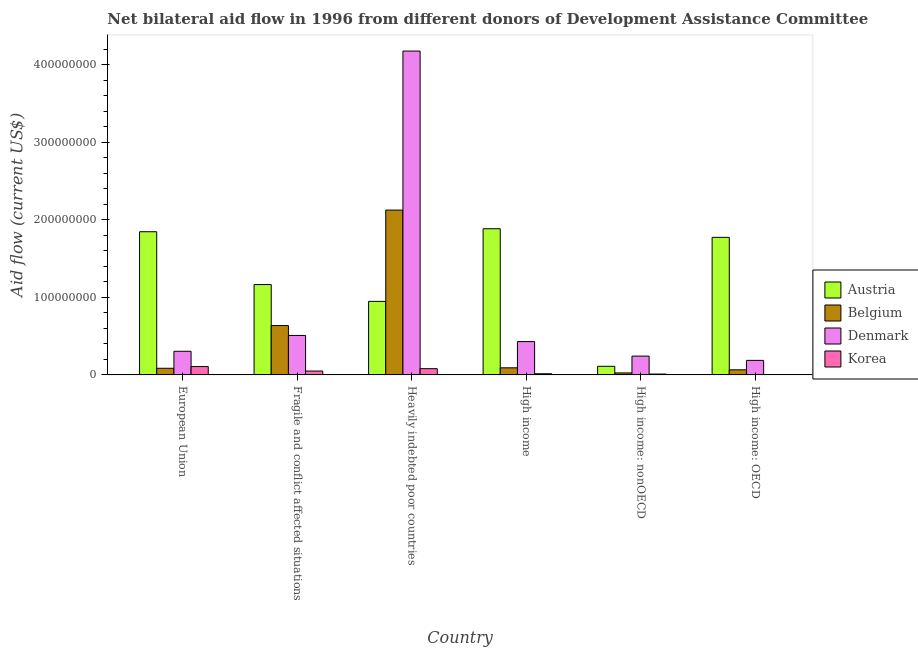How many different coloured bars are there?
Keep it short and to the point. 4. Are the number of bars on each tick of the X-axis equal?
Make the answer very short. Yes. How many bars are there on the 3rd tick from the right?
Keep it short and to the point. 4. What is the label of the 1st group of bars from the left?
Your response must be concise. European Union. What is the amount of aid given by denmark in Fragile and conflict affected situations?
Provide a short and direct response. 5.09e+07. Across all countries, what is the maximum amount of aid given by korea?
Your answer should be very brief. 1.08e+07. Across all countries, what is the minimum amount of aid given by korea?
Offer a terse response. 3.50e+05. In which country was the amount of aid given by korea maximum?
Offer a terse response. European Union. In which country was the amount of aid given by korea minimum?
Offer a terse response. High income: OECD. What is the total amount of aid given by austria in the graph?
Give a very brief answer. 7.73e+08. What is the difference between the amount of aid given by denmark in European Union and that in High income: OECD?
Make the answer very short. 1.17e+07. What is the difference between the amount of aid given by denmark in European Union and the amount of aid given by belgium in Heavily indebted poor countries?
Keep it short and to the point. -1.82e+08. What is the average amount of aid given by denmark per country?
Offer a terse response. 9.75e+07. What is the difference between the amount of aid given by denmark and amount of aid given by austria in European Union?
Your response must be concise. -1.54e+08. What is the ratio of the amount of aid given by austria in European Union to that in High income: OECD?
Your answer should be compact. 1.04. Is the amount of aid given by belgium in Fragile and conflict affected situations less than that in High income: nonOECD?
Ensure brevity in your answer.  No. What is the difference between the highest and the second highest amount of aid given by belgium?
Offer a very short reply. 1.49e+08. What is the difference between the highest and the lowest amount of aid given by austria?
Give a very brief answer. 1.77e+08. In how many countries, is the amount of aid given by belgium greater than the average amount of aid given by belgium taken over all countries?
Your response must be concise. 2. What does the 1st bar from the right in Fragile and conflict affected situations represents?
Provide a succinct answer. Korea. Is it the case that in every country, the sum of the amount of aid given by austria and amount of aid given by belgium is greater than the amount of aid given by denmark?
Give a very brief answer. No. How many bars are there?
Make the answer very short. 24. Are all the bars in the graph horizontal?
Your answer should be compact. No. What is the difference between two consecutive major ticks on the Y-axis?
Your answer should be very brief. 1.00e+08. Are the values on the major ticks of Y-axis written in scientific E-notation?
Keep it short and to the point. No. Where does the legend appear in the graph?
Your response must be concise. Center right. How many legend labels are there?
Provide a short and direct response. 4. How are the legend labels stacked?
Provide a succinct answer. Vertical. What is the title of the graph?
Keep it short and to the point. Net bilateral aid flow in 1996 from different donors of Development Assistance Committee. What is the label or title of the X-axis?
Give a very brief answer. Country. What is the Aid flow (current US$) in Austria in European Union?
Keep it short and to the point. 1.85e+08. What is the Aid flow (current US$) in Belgium in European Union?
Offer a very short reply. 8.55e+06. What is the Aid flow (current US$) of Denmark in European Union?
Offer a very short reply. 3.05e+07. What is the Aid flow (current US$) in Korea in European Union?
Offer a terse response. 1.08e+07. What is the Aid flow (current US$) of Austria in Fragile and conflict affected situations?
Offer a terse response. 1.16e+08. What is the Aid flow (current US$) in Belgium in Fragile and conflict affected situations?
Provide a succinct answer. 6.36e+07. What is the Aid flow (current US$) of Denmark in Fragile and conflict affected situations?
Offer a terse response. 5.09e+07. What is the Aid flow (current US$) of Korea in Fragile and conflict affected situations?
Ensure brevity in your answer.  5.00e+06. What is the Aid flow (current US$) of Austria in Heavily indebted poor countries?
Give a very brief answer. 9.48e+07. What is the Aid flow (current US$) of Belgium in Heavily indebted poor countries?
Give a very brief answer. 2.12e+08. What is the Aid flow (current US$) in Denmark in Heavily indebted poor countries?
Offer a very short reply. 4.17e+08. What is the Aid flow (current US$) of Korea in Heavily indebted poor countries?
Provide a succinct answer. 8.06e+06. What is the Aid flow (current US$) of Austria in High income?
Keep it short and to the point. 1.88e+08. What is the Aid flow (current US$) of Belgium in High income?
Your response must be concise. 9.15e+06. What is the Aid flow (current US$) of Denmark in High income?
Keep it short and to the point. 4.30e+07. What is the Aid flow (current US$) in Korea in High income?
Provide a succinct answer. 1.48e+06. What is the Aid flow (current US$) in Austria in High income: nonOECD?
Make the answer very short. 1.11e+07. What is the Aid flow (current US$) of Belgium in High income: nonOECD?
Your answer should be compact. 2.58e+06. What is the Aid flow (current US$) in Denmark in High income: nonOECD?
Your response must be concise. 2.42e+07. What is the Aid flow (current US$) in Korea in High income: nonOECD?
Keep it short and to the point. 1.13e+06. What is the Aid flow (current US$) of Austria in High income: OECD?
Your response must be concise. 1.77e+08. What is the Aid flow (current US$) in Belgium in High income: OECD?
Your response must be concise. 6.57e+06. What is the Aid flow (current US$) of Denmark in High income: OECD?
Your answer should be compact. 1.87e+07. What is the Aid flow (current US$) of Korea in High income: OECD?
Offer a terse response. 3.50e+05. Across all countries, what is the maximum Aid flow (current US$) in Austria?
Offer a terse response. 1.88e+08. Across all countries, what is the maximum Aid flow (current US$) of Belgium?
Provide a short and direct response. 2.12e+08. Across all countries, what is the maximum Aid flow (current US$) of Denmark?
Offer a very short reply. 4.17e+08. Across all countries, what is the maximum Aid flow (current US$) in Korea?
Offer a very short reply. 1.08e+07. Across all countries, what is the minimum Aid flow (current US$) in Austria?
Provide a short and direct response. 1.11e+07. Across all countries, what is the minimum Aid flow (current US$) of Belgium?
Your answer should be very brief. 2.58e+06. Across all countries, what is the minimum Aid flow (current US$) in Denmark?
Provide a succinct answer. 1.87e+07. Across all countries, what is the minimum Aid flow (current US$) of Korea?
Provide a short and direct response. 3.50e+05. What is the total Aid flow (current US$) in Austria in the graph?
Give a very brief answer. 7.73e+08. What is the total Aid flow (current US$) in Belgium in the graph?
Ensure brevity in your answer.  3.03e+08. What is the total Aid flow (current US$) in Denmark in the graph?
Offer a terse response. 5.85e+08. What is the total Aid flow (current US$) in Korea in the graph?
Provide a succinct answer. 2.68e+07. What is the difference between the Aid flow (current US$) of Austria in European Union and that in Fragile and conflict affected situations?
Provide a succinct answer. 6.81e+07. What is the difference between the Aid flow (current US$) of Belgium in European Union and that in Fragile and conflict affected situations?
Ensure brevity in your answer.  -5.50e+07. What is the difference between the Aid flow (current US$) of Denmark in European Union and that in Fragile and conflict affected situations?
Your response must be concise. -2.04e+07. What is the difference between the Aid flow (current US$) in Korea in European Union and that in Fragile and conflict affected situations?
Provide a short and direct response. 5.77e+06. What is the difference between the Aid flow (current US$) of Austria in European Union and that in Heavily indebted poor countries?
Make the answer very short. 8.98e+07. What is the difference between the Aid flow (current US$) in Belgium in European Union and that in Heavily indebted poor countries?
Your response must be concise. -2.04e+08. What is the difference between the Aid flow (current US$) in Denmark in European Union and that in Heavily indebted poor countries?
Your answer should be compact. -3.87e+08. What is the difference between the Aid flow (current US$) in Korea in European Union and that in Heavily indebted poor countries?
Make the answer very short. 2.71e+06. What is the difference between the Aid flow (current US$) in Austria in European Union and that in High income?
Give a very brief answer. -3.84e+06. What is the difference between the Aid flow (current US$) in Belgium in European Union and that in High income?
Your answer should be very brief. -6.00e+05. What is the difference between the Aid flow (current US$) of Denmark in European Union and that in High income?
Make the answer very short. -1.25e+07. What is the difference between the Aid flow (current US$) in Korea in European Union and that in High income?
Offer a very short reply. 9.29e+06. What is the difference between the Aid flow (current US$) in Austria in European Union and that in High income: nonOECD?
Give a very brief answer. 1.74e+08. What is the difference between the Aid flow (current US$) in Belgium in European Union and that in High income: nonOECD?
Provide a succinct answer. 5.97e+06. What is the difference between the Aid flow (current US$) in Denmark in European Union and that in High income: nonOECD?
Keep it short and to the point. 6.23e+06. What is the difference between the Aid flow (current US$) of Korea in European Union and that in High income: nonOECD?
Keep it short and to the point. 9.64e+06. What is the difference between the Aid flow (current US$) of Austria in European Union and that in High income: OECD?
Keep it short and to the point. 7.25e+06. What is the difference between the Aid flow (current US$) of Belgium in European Union and that in High income: OECD?
Ensure brevity in your answer.  1.98e+06. What is the difference between the Aid flow (current US$) in Denmark in European Union and that in High income: OECD?
Ensure brevity in your answer.  1.17e+07. What is the difference between the Aid flow (current US$) of Korea in European Union and that in High income: OECD?
Offer a very short reply. 1.04e+07. What is the difference between the Aid flow (current US$) of Austria in Fragile and conflict affected situations and that in Heavily indebted poor countries?
Offer a very short reply. 2.17e+07. What is the difference between the Aid flow (current US$) of Belgium in Fragile and conflict affected situations and that in Heavily indebted poor countries?
Provide a short and direct response. -1.49e+08. What is the difference between the Aid flow (current US$) of Denmark in Fragile and conflict affected situations and that in Heavily indebted poor countries?
Provide a short and direct response. -3.67e+08. What is the difference between the Aid flow (current US$) in Korea in Fragile and conflict affected situations and that in Heavily indebted poor countries?
Make the answer very short. -3.06e+06. What is the difference between the Aid flow (current US$) of Austria in Fragile and conflict affected situations and that in High income?
Offer a very short reply. -7.19e+07. What is the difference between the Aid flow (current US$) of Belgium in Fragile and conflict affected situations and that in High income?
Make the answer very short. 5.44e+07. What is the difference between the Aid flow (current US$) of Denmark in Fragile and conflict affected situations and that in High income?
Your answer should be very brief. 7.90e+06. What is the difference between the Aid flow (current US$) in Korea in Fragile and conflict affected situations and that in High income?
Make the answer very short. 3.52e+06. What is the difference between the Aid flow (current US$) in Austria in Fragile and conflict affected situations and that in High income: nonOECD?
Provide a succinct answer. 1.05e+08. What is the difference between the Aid flow (current US$) in Belgium in Fragile and conflict affected situations and that in High income: nonOECD?
Your answer should be compact. 6.10e+07. What is the difference between the Aid flow (current US$) of Denmark in Fragile and conflict affected situations and that in High income: nonOECD?
Give a very brief answer. 2.66e+07. What is the difference between the Aid flow (current US$) of Korea in Fragile and conflict affected situations and that in High income: nonOECD?
Keep it short and to the point. 3.87e+06. What is the difference between the Aid flow (current US$) of Austria in Fragile and conflict affected situations and that in High income: OECD?
Your response must be concise. -6.08e+07. What is the difference between the Aid flow (current US$) in Belgium in Fragile and conflict affected situations and that in High income: OECD?
Your answer should be compact. 5.70e+07. What is the difference between the Aid flow (current US$) in Denmark in Fragile and conflict affected situations and that in High income: OECD?
Your answer should be compact. 3.21e+07. What is the difference between the Aid flow (current US$) of Korea in Fragile and conflict affected situations and that in High income: OECD?
Keep it short and to the point. 4.65e+06. What is the difference between the Aid flow (current US$) in Austria in Heavily indebted poor countries and that in High income?
Provide a succinct answer. -9.36e+07. What is the difference between the Aid flow (current US$) in Belgium in Heavily indebted poor countries and that in High income?
Offer a terse response. 2.03e+08. What is the difference between the Aid flow (current US$) in Denmark in Heavily indebted poor countries and that in High income?
Offer a terse response. 3.75e+08. What is the difference between the Aid flow (current US$) in Korea in Heavily indebted poor countries and that in High income?
Give a very brief answer. 6.58e+06. What is the difference between the Aid flow (current US$) of Austria in Heavily indebted poor countries and that in High income: nonOECD?
Ensure brevity in your answer.  8.37e+07. What is the difference between the Aid flow (current US$) in Belgium in Heavily indebted poor countries and that in High income: nonOECD?
Provide a short and direct response. 2.10e+08. What is the difference between the Aid flow (current US$) in Denmark in Heavily indebted poor countries and that in High income: nonOECD?
Offer a very short reply. 3.93e+08. What is the difference between the Aid flow (current US$) of Korea in Heavily indebted poor countries and that in High income: nonOECD?
Offer a terse response. 6.93e+06. What is the difference between the Aid flow (current US$) in Austria in Heavily indebted poor countries and that in High income: OECD?
Keep it short and to the point. -8.26e+07. What is the difference between the Aid flow (current US$) of Belgium in Heavily indebted poor countries and that in High income: OECD?
Make the answer very short. 2.06e+08. What is the difference between the Aid flow (current US$) of Denmark in Heavily indebted poor countries and that in High income: OECD?
Provide a short and direct response. 3.99e+08. What is the difference between the Aid flow (current US$) in Korea in Heavily indebted poor countries and that in High income: OECD?
Make the answer very short. 7.71e+06. What is the difference between the Aid flow (current US$) in Austria in High income and that in High income: nonOECD?
Ensure brevity in your answer.  1.77e+08. What is the difference between the Aid flow (current US$) of Belgium in High income and that in High income: nonOECD?
Provide a succinct answer. 6.57e+06. What is the difference between the Aid flow (current US$) of Denmark in High income and that in High income: nonOECD?
Offer a very short reply. 1.87e+07. What is the difference between the Aid flow (current US$) in Korea in High income and that in High income: nonOECD?
Provide a short and direct response. 3.50e+05. What is the difference between the Aid flow (current US$) in Austria in High income and that in High income: OECD?
Keep it short and to the point. 1.11e+07. What is the difference between the Aid flow (current US$) in Belgium in High income and that in High income: OECD?
Your answer should be very brief. 2.58e+06. What is the difference between the Aid flow (current US$) of Denmark in High income and that in High income: OECD?
Your response must be concise. 2.42e+07. What is the difference between the Aid flow (current US$) of Korea in High income and that in High income: OECD?
Your answer should be compact. 1.13e+06. What is the difference between the Aid flow (current US$) in Austria in High income: nonOECD and that in High income: OECD?
Provide a succinct answer. -1.66e+08. What is the difference between the Aid flow (current US$) of Belgium in High income: nonOECD and that in High income: OECD?
Provide a short and direct response. -3.99e+06. What is the difference between the Aid flow (current US$) of Denmark in High income: nonOECD and that in High income: OECD?
Keep it short and to the point. 5.51e+06. What is the difference between the Aid flow (current US$) of Korea in High income: nonOECD and that in High income: OECD?
Provide a short and direct response. 7.80e+05. What is the difference between the Aid flow (current US$) in Austria in European Union and the Aid flow (current US$) in Belgium in Fragile and conflict affected situations?
Keep it short and to the point. 1.21e+08. What is the difference between the Aid flow (current US$) in Austria in European Union and the Aid flow (current US$) in Denmark in Fragile and conflict affected situations?
Make the answer very short. 1.34e+08. What is the difference between the Aid flow (current US$) of Austria in European Union and the Aid flow (current US$) of Korea in Fragile and conflict affected situations?
Your answer should be compact. 1.80e+08. What is the difference between the Aid flow (current US$) in Belgium in European Union and the Aid flow (current US$) in Denmark in Fragile and conflict affected situations?
Your answer should be very brief. -4.23e+07. What is the difference between the Aid flow (current US$) in Belgium in European Union and the Aid flow (current US$) in Korea in Fragile and conflict affected situations?
Ensure brevity in your answer.  3.55e+06. What is the difference between the Aid flow (current US$) of Denmark in European Union and the Aid flow (current US$) of Korea in Fragile and conflict affected situations?
Ensure brevity in your answer.  2.55e+07. What is the difference between the Aid flow (current US$) in Austria in European Union and the Aid flow (current US$) in Belgium in Heavily indebted poor countries?
Your response must be concise. -2.79e+07. What is the difference between the Aid flow (current US$) in Austria in European Union and the Aid flow (current US$) in Denmark in Heavily indebted poor countries?
Your response must be concise. -2.33e+08. What is the difference between the Aid flow (current US$) of Austria in European Union and the Aid flow (current US$) of Korea in Heavily indebted poor countries?
Your answer should be compact. 1.77e+08. What is the difference between the Aid flow (current US$) of Belgium in European Union and the Aid flow (current US$) of Denmark in Heavily indebted poor countries?
Keep it short and to the point. -4.09e+08. What is the difference between the Aid flow (current US$) in Denmark in European Union and the Aid flow (current US$) in Korea in Heavily indebted poor countries?
Make the answer very short. 2.24e+07. What is the difference between the Aid flow (current US$) in Austria in European Union and the Aid flow (current US$) in Belgium in High income?
Offer a very short reply. 1.75e+08. What is the difference between the Aid flow (current US$) in Austria in European Union and the Aid flow (current US$) in Denmark in High income?
Your answer should be compact. 1.42e+08. What is the difference between the Aid flow (current US$) of Austria in European Union and the Aid flow (current US$) of Korea in High income?
Offer a very short reply. 1.83e+08. What is the difference between the Aid flow (current US$) of Belgium in European Union and the Aid flow (current US$) of Denmark in High income?
Your answer should be compact. -3.44e+07. What is the difference between the Aid flow (current US$) in Belgium in European Union and the Aid flow (current US$) in Korea in High income?
Your response must be concise. 7.07e+06. What is the difference between the Aid flow (current US$) in Denmark in European Union and the Aid flow (current US$) in Korea in High income?
Your response must be concise. 2.90e+07. What is the difference between the Aid flow (current US$) in Austria in European Union and the Aid flow (current US$) in Belgium in High income: nonOECD?
Provide a short and direct response. 1.82e+08. What is the difference between the Aid flow (current US$) of Austria in European Union and the Aid flow (current US$) of Denmark in High income: nonOECD?
Keep it short and to the point. 1.60e+08. What is the difference between the Aid flow (current US$) in Austria in European Union and the Aid flow (current US$) in Korea in High income: nonOECD?
Make the answer very short. 1.83e+08. What is the difference between the Aid flow (current US$) of Belgium in European Union and the Aid flow (current US$) of Denmark in High income: nonOECD?
Your answer should be compact. -1.57e+07. What is the difference between the Aid flow (current US$) of Belgium in European Union and the Aid flow (current US$) of Korea in High income: nonOECD?
Ensure brevity in your answer.  7.42e+06. What is the difference between the Aid flow (current US$) in Denmark in European Union and the Aid flow (current US$) in Korea in High income: nonOECD?
Give a very brief answer. 2.93e+07. What is the difference between the Aid flow (current US$) of Austria in European Union and the Aid flow (current US$) of Belgium in High income: OECD?
Your answer should be very brief. 1.78e+08. What is the difference between the Aid flow (current US$) in Austria in European Union and the Aid flow (current US$) in Denmark in High income: OECD?
Ensure brevity in your answer.  1.66e+08. What is the difference between the Aid flow (current US$) in Austria in European Union and the Aid flow (current US$) in Korea in High income: OECD?
Make the answer very short. 1.84e+08. What is the difference between the Aid flow (current US$) in Belgium in European Union and the Aid flow (current US$) in Denmark in High income: OECD?
Offer a terse response. -1.02e+07. What is the difference between the Aid flow (current US$) in Belgium in European Union and the Aid flow (current US$) in Korea in High income: OECD?
Your answer should be very brief. 8.20e+06. What is the difference between the Aid flow (current US$) of Denmark in European Union and the Aid flow (current US$) of Korea in High income: OECD?
Ensure brevity in your answer.  3.01e+07. What is the difference between the Aid flow (current US$) of Austria in Fragile and conflict affected situations and the Aid flow (current US$) of Belgium in Heavily indebted poor countries?
Your answer should be compact. -9.60e+07. What is the difference between the Aid flow (current US$) of Austria in Fragile and conflict affected situations and the Aid flow (current US$) of Denmark in Heavily indebted poor countries?
Offer a terse response. -3.01e+08. What is the difference between the Aid flow (current US$) in Austria in Fragile and conflict affected situations and the Aid flow (current US$) in Korea in Heavily indebted poor countries?
Your response must be concise. 1.08e+08. What is the difference between the Aid flow (current US$) of Belgium in Fragile and conflict affected situations and the Aid flow (current US$) of Denmark in Heavily indebted poor countries?
Offer a very short reply. -3.54e+08. What is the difference between the Aid flow (current US$) in Belgium in Fragile and conflict affected situations and the Aid flow (current US$) in Korea in Heavily indebted poor countries?
Offer a terse response. 5.55e+07. What is the difference between the Aid flow (current US$) in Denmark in Fragile and conflict affected situations and the Aid flow (current US$) in Korea in Heavily indebted poor countries?
Your answer should be very brief. 4.28e+07. What is the difference between the Aid flow (current US$) in Austria in Fragile and conflict affected situations and the Aid flow (current US$) in Belgium in High income?
Make the answer very short. 1.07e+08. What is the difference between the Aid flow (current US$) of Austria in Fragile and conflict affected situations and the Aid flow (current US$) of Denmark in High income?
Provide a succinct answer. 7.35e+07. What is the difference between the Aid flow (current US$) in Austria in Fragile and conflict affected situations and the Aid flow (current US$) in Korea in High income?
Give a very brief answer. 1.15e+08. What is the difference between the Aid flow (current US$) of Belgium in Fragile and conflict affected situations and the Aid flow (current US$) of Denmark in High income?
Provide a succinct answer. 2.06e+07. What is the difference between the Aid flow (current US$) in Belgium in Fragile and conflict affected situations and the Aid flow (current US$) in Korea in High income?
Offer a very short reply. 6.21e+07. What is the difference between the Aid flow (current US$) in Denmark in Fragile and conflict affected situations and the Aid flow (current US$) in Korea in High income?
Give a very brief answer. 4.94e+07. What is the difference between the Aid flow (current US$) of Austria in Fragile and conflict affected situations and the Aid flow (current US$) of Belgium in High income: nonOECD?
Your response must be concise. 1.14e+08. What is the difference between the Aid flow (current US$) in Austria in Fragile and conflict affected situations and the Aid flow (current US$) in Denmark in High income: nonOECD?
Provide a short and direct response. 9.22e+07. What is the difference between the Aid flow (current US$) of Austria in Fragile and conflict affected situations and the Aid flow (current US$) of Korea in High income: nonOECD?
Provide a succinct answer. 1.15e+08. What is the difference between the Aid flow (current US$) of Belgium in Fragile and conflict affected situations and the Aid flow (current US$) of Denmark in High income: nonOECD?
Offer a terse response. 3.94e+07. What is the difference between the Aid flow (current US$) in Belgium in Fragile and conflict affected situations and the Aid flow (current US$) in Korea in High income: nonOECD?
Provide a short and direct response. 6.25e+07. What is the difference between the Aid flow (current US$) in Denmark in Fragile and conflict affected situations and the Aid flow (current US$) in Korea in High income: nonOECD?
Offer a terse response. 4.97e+07. What is the difference between the Aid flow (current US$) of Austria in Fragile and conflict affected situations and the Aid flow (current US$) of Belgium in High income: OECD?
Give a very brief answer. 1.10e+08. What is the difference between the Aid flow (current US$) in Austria in Fragile and conflict affected situations and the Aid flow (current US$) in Denmark in High income: OECD?
Give a very brief answer. 9.78e+07. What is the difference between the Aid flow (current US$) in Austria in Fragile and conflict affected situations and the Aid flow (current US$) in Korea in High income: OECD?
Make the answer very short. 1.16e+08. What is the difference between the Aid flow (current US$) of Belgium in Fragile and conflict affected situations and the Aid flow (current US$) of Denmark in High income: OECD?
Give a very brief answer. 4.49e+07. What is the difference between the Aid flow (current US$) in Belgium in Fragile and conflict affected situations and the Aid flow (current US$) in Korea in High income: OECD?
Ensure brevity in your answer.  6.32e+07. What is the difference between the Aid flow (current US$) of Denmark in Fragile and conflict affected situations and the Aid flow (current US$) of Korea in High income: OECD?
Your response must be concise. 5.05e+07. What is the difference between the Aid flow (current US$) of Austria in Heavily indebted poor countries and the Aid flow (current US$) of Belgium in High income?
Offer a very short reply. 8.56e+07. What is the difference between the Aid flow (current US$) in Austria in Heavily indebted poor countries and the Aid flow (current US$) in Denmark in High income?
Provide a succinct answer. 5.18e+07. What is the difference between the Aid flow (current US$) of Austria in Heavily indebted poor countries and the Aid flow (current US$) of Korea in High income?
Provide a succinct answer. 9.33e+07. What is the difference between the Aid flow (current US$) in Belgium in Heavily indebted poor countries and the Aid flow (current US$) in Denmark in High income?
Offer a very short reply. 1.70e+08. What is the difference between the Aid flow (current US$) in Belgium in Heavily indebted poor countries and the Aid flow (current US$) in Korea in High income?
Keep it short and to the point. 2.11e+08. What is the difference between the Aid flow (current US$) in Denmark in Heavily indebted poor countries and the Aid flow (current US$) in Korea in High income?
Provide a short and direct response. 4.16e+08. What is the difference between the Aid flow (current US$) of Austria in Heavily indebted poor countries and the Aid flow (current US$) of Belgium in High income: nonOECD?
Keep it short and to the point. 9.22e+07. What is the difference between the Aid flow (current US$) of Austria in Heavily indebted poor countries and the Aid flow (current US$) of Denmark in High income: nonOECD?
Your response must be concise. 7.06e+07. What is the difference between the Aid flow (current US$) in Austria in Heavily indebted poor countries and the Aid flow (current US$) in Korea in High income: nonOECD?
Keep it short and to the point. 9.37e+07. What is the difference between the Aid flow (current US$) of Belgium in Heavily indebted poor countries and the Aid flow (current US$) of Denmark in High income: nonOECD?
Ensure brevity in your answer.  1.88e+08. What is the difference between the Aid flow (current US$) of Belgium in Heavily indebted poor countries and the Aid flow (current US$) of Korea in High income: nonOECD?
Offer a very short reply. 2.11e+08. What is the difference between the Aid flow (current US$) in Denmark in Heavily indebted poor countries and the Aid flow (current US$) in Korea in High income: nonOECD?
Your response must be concise. 4.16e+08. What is the difference between the Aid flow (current US$) in Austria in Heavily indebted poor countries and the Aid flow (current US$) in Belgium in High income: OECD?
Provide a short and direct response. 8.82e+07. What is the difference between the Aid flow (current US$) of Austria in Heavily indebted poor countries and the Aid flow (current US$) of Denmark in High income: OECD?
Offer a terse response. 7.61e+07. What is the difference between the Aid flow (current US$) in Austria in Heavily indebted poor countries and the Aid flow (current US$) in Korea in High income: OECD?
Your answer should be compact. 9.44e+07. What is the difference between the Aid flow (current US$) in Belgium in Heavily indebted poor countries and the Aid flow (current US$) in Denmark in High income: OECD?
Your answer should be very brief. 1.94e+08. What is the difference between the Aid flow (current US$) in Belgium in Heavily indebted poor countries and the Aid flow (current US$) in Korea in High income: OECD?
Your answer should be compact. 2.12e+08. What is the difference between the Aid flow (current US$) in Denmark in Heavily indebted poor countries and the Aid flow (current US$) in Korea in High income: OECD?
Offer a terse response. 4.17e+08. What is the difference between the Aid flow (current US$) of Austria in High income and the Aid flow (current US$) of Belgium in High income: nonOECD?
Provide a succinct answer. 1.86e+08. What is the difference between the Aid flow (current US$) in Austria in High income and the Aid flow (current US$) in Denmark in High income: nonOECD?
Your answer should be compact. 1.64e+08. What is the difference between the Aid flow (current US$) in Austria in High income and the Aid flow (current US$) in Korea in High income: nonOECD?
Your answer should be very brief. 1.87e+08. What is the difference between the Aid flow (current US$) of Belgium in High income and the Aid flow (current US$) of Denmark in High income: nonOECD?
Provide a short and direct response. -1.51e+07. What is the difference between the Aid flow (current US$) of Belgium in High income and the Aid flow (current US$) of Korea in High income: nonOECD?
Your response must be concise. 8.02e+06. What is the difference between the Aid flow (current US$) of Denmark in High income and the Aid flow (current US$) of Korea in High income: nonOECD?
Offer a terse response. 4.18e+07. What is the difference between the Aid flow (current US$) in Austria in High income and the Aid flow (current US$) in Belgium in High income: OECD?
Your answer should be very brief. 1.82e+08. What is the difference between the Aid flow (current US$) in Austria in High income and the Aid flow (current US$) in Denmark in High income: OECD?
Keep it short and to the point. 1.70e+08. What is the difference between the Aid flow (current US$) of Austria in High income and the Aid flow (current US$) of Korea in High income: OECD?
Your answer should be compact. 1.88e+08. What is the difference between the Aid flow (current US$) in Belgium in High income and the Aid flow (current US$) in Denmark in High income: OECD?
Provide a short and direct response. -9.58e+06. What is the difference between the Aid flow (current US$) in Belgium in High income and the Aid flow (current US$) in Korea in High income: OECD?
Your answer should be compact. 8.80e+06. What is the difference between the Aid flow (current US$) in Denmark in High income and the Aid flow (current US$) in Korea in High income: OECD?
Ensure brevity in your answer.  4.26e+07. What is the difference between the Aid flow (current US$) of Austria in High income: nonOECD and the Aid flow (current US$) of Belgium in High income: OECD?
Your answer should be compact. 4.52e+06. What is the difference between the Aid flow (current US$) of Austria in High income: nonOECD and the Aid flow (current US$) of Denmark in High income: OECD?
Your response must be concise. -7.64e+06. What is the difference between the Aid flow (current US$) of Austria in High income: nonOECD and the Aid flow (current US$) of Korea in High income: OECD?
Make the answer very short. 1.07e+07. What is the difference between the Aid flow (current US$) of Belgium in High income: nonOECD and the Aid flow (current US$) of Denmark in High income: OECD?
Provide a short and direct response. -1.62e+07. What is the difference between the Aid flow (current US$) in Belgium in High income: nonOECD and the Aid flow (current US$) in Korea in High income: OECD?
Your answer should be compact. 2.23e+06. What is the difference between the Aid flow (current US$) in Denmark in High income: nonOECD and the Aid flow (current US$) in Korea in High income: OECD?
Provide a succinct answer. 2.39e+07. What is the average Aid flow (current US$) in Austria per country?
Your answer should be very brief. 1.29e+08. What is the average Aid flow (current US$) of Belgium per country?
Your answer should be very brief. 5.05e+07. What is the average Aid flow (current US$) of Denmark per country?
Provide a short and direct response. 9.75e+07. What is the average Aid flow (current US$) of Korea per country?
Your answer should be compact. 4.46e+06. What is the difference between the Aid flow (current US$) in Austria and Aid flow (current US$) in Belgium in European Union?
Give a very brief answer. 1.76e+08. What is the difference between the Aid flow (current US$) in Austria and Aid flow (current US$) in Denmark in European Union?
Provide a succinct answer. 1.54e+08. What is the difference between the Aid flow (current US$) in Austria and Aid flow (current US$) in Korea in European Union?
Ensure brevity in your answer.  1.74e+08. What is the difference between the Aid flow (current US$) in Belgium and Aid flow (current US$) in Denmark in European Union?
Ensure brevity in your answer.  -2.19e+07. What is the difference between the Aid flow (current US$) of Belgium and Aid flow (current US$) of Korea in European Union?
Give a very brief answer. -2.22e+06. What is the difference between the Aid flow (current US$) in Denmark and Aid flow (current US$) in Korea in European Union?
Your response must be concise. 1.97e+07. What is the difference between the Aid flow (current US$) in Austria and Aid flow (current US$) in Belgium in Fragile and conflict affected situations?
Your answer should be compact. 5.29e+07. What is the difference between the Aid flow (current US$) of Austria and Aid flow (current US$) of Denmark in Fragile and conflict affected situations?
Your answer should be very brief. 6.56e+07. What is the difference between the Aid flow (current US$) of Austria and Aid flow (current US$) of Korea in Fragile and conflict affected situations?
Provide a succinct answer. 1.11e+08. What is the difference between the Aid flow (current US$) in Belgium and Aid flow (current US$) in Denmark in Fragile and conflict affected situations?
Provide a short and direct response. 1.27e+07. What is the difference between the Aid flow (current US$) in Belgium and Aid flow (current US$) in Korea in Fragile and conflict affected situations?
Offer a terse response. 5.86e+07. What is the difference between the Aid flow (current US$) in Denmark and Aid flow (current US$) in Korea in Fragile and conflict affected situations?
Your response must be concise. 4.59e+07. What is the difference between the Aid flow (current US$) of Austria and Aid flow (current US$) of Belgium in Heavily indebted poor countries?
Your answer should be compact. -1.18e+08. What is the difference between the Aid flow (current US$) in Austria and Aid flow (current US$) in Denmark in Heavily indebted poor countries?
Your answer should be compact. -3.23e+08. What is the difference between the Aid flow (current US$) in Austria and Aid flow (current US$) in Korea in Heavily indebted poor countries?
Your response must be concise. 8.67e+07. What is the difference between the Aid flow (current US$) in Belgium and Aid flow (current US$) in Denmark in Heavily indebted poor countries?
Offer a very short reply. -2.05e+08. What is the difference between the Aid flow (current US$) in Belgium and Aid flow (current US$) in Korea in Heavily indebted poor countries?
Make the answer very short. 2.04e+08. What is the difference between the Aid flow (current US$) in Denmark and Aid flow (current US$) in Korea in Heavily indebted poor countries?
Provide a succinct answer. 4.09e+08. What is the difference between the Aid flow (current US$) in Austria and Aid flow (current US$) in Belgium in High income?
Ensure brevity in your answer.  1.79e+08. What is the difference between the Aid flow (current US$) in Austria and Aid flow (current US$) in Denmark in High income?
Make the answer very short. 1.45e+08. What is the difference between the Aid flow (current US$) of Austria and Aid flow (current US$) of Korea in High income?
Your answer should be compact. 1.87e+08. What is the difference between the Aid flow (current US$) of Belgium and Aid flow (current US$) of Denmark in High income?
Offer a very short reply. -3.38e+07. What is the difference between the Aid flow (current US$) in Belgium and Aid flow (current US$) in Korea in High income?
Your answer should be very brief. 7.67e+06. What is the difference between the Aid flow (current US$) of Denmark and Aid flow (current US$) of Korea in High income?
Your answer should be compact. 4.15e+07. What is the difference between the Aid flow (current US$) of Austria and Aid flow (current US$) of Belgium in High income: nonOECD?
Provide a succinct answer. 8.51e+06. What is the difference between the Aid flow (current US$) of Austria and Aid flow (current US$) of Denmark in High income: nonOECD?
Your answer should be very brief. -1.32e+07. What is the difference between the Aid flow (current US$) in Austria and Aid flow (current US$) in Korea in High income: nonOECD?
Offer a very short reply. 9.96e+06. What is the difference between the Aid flow (current US$) of Belgium and Aid flow (current US$) of Denmark in High income: nonOECD?
Offer a terse response. -2.17e+07. What is the difference between the Aid flow (current US$) in Belgium and Aid flow (current US$) in Korea in High income: nonOECD?
Provide a succinct answer. 1.45e+06. What is the difference between the Aid flow (current US$) of Denmark and Aid flow (current US$) of Korea in High income: nonOECD?
Offer a terse response. 2.31e+07. What is the difference between the Aid flow (current US$) in Austria and Aid flow (current US$) in Belgium in High income: OECD?
Keep it short and to the point. 1.71e+08. What is the difference between the Aid flow (current US$) of Austria and Aid flow (current US$) of Denmark in High income: OECD?
Your answer should be very brief. 1.59e+08. What is the difference between the Aid flow (current US$) in Austria and Aid flow (current US$) in Korea in High income: OECD?
Your response must be concise. 1.77e+08. What is the difference between the Aid flow (current US$) of Belgium and Aid flow (current US$) of Denmark in High income: OECD?
Ensure brevity in your answer.  -1.22e+07. What is the difference between the Aid flow (current US$) of Belgium and Aid flow (current US$) of Korea in High income: OECD?
Keep it short and to the point. 6.22e+06. What is the difference between the Aid flow (current US$) of Denmark and Aid flow (current US$) of Korea in High income: OECD?
Give a very brief answer. 1.84e+07. What is the ratio of the Aid flow (current US$) of Austria in European Union to that in Fragile and conflict affected situations?
Provide a succinct answer. 1.58. What is the ratio of the Aid flow (current US$) of Belgium in European Union to that in Fragile and conflict affected situations?
Make the answer very short. 0.13. What is the ratio of the Aid flow (current US$) of Denmark in European Union to that in Fragile and conflict affected situations?
Your answer should be compact. 0.6. What is the ratio of the Aid flow (current US$) in Korea in European Union to that in Fragile and conflict affected situations?
Offer a terse response. 2.15. What is the ratio of the Aid flow (current US$) of Austria in European Union to that in Heavily indebted poor countries?
Give a very brief answer. 1.95. What is the ratio of the Aid flow (current US$) in Belgium in European Union to that in Heavily indebted poor countries?
Offer a very short reply. 0.04. What is the ratio of the Aid flow (current US$) of Denmark in European Union to that in Heavily indebted poor countries?
Provide a short and direct response. 0.07. What is the ratio of the Aid flow (current US$) in Korea in European Union to that in Heavily indebted poor countries?
Your response must be concise. 1.34. What is the ratio of the Aid flow (current US$) of Austria in European Union to that in High income?
Provide a short and direct response. 0.98. What is the ratio of the Aid flow (current US$) of Belgium in European Union to that in High income?
Ensure brevity in your answer.  0.93. What is the ratio of the Aid flow (current US$) in Denmark in European Union to that in High income?
Offer a terse response. 0.71. What is the ratio of the Aid flow (current US$) of Korea in European Union to that in High income?
Ensure brevity in your answer.  7.28. What is the ratio of the Aid flow (current US$) of Austria in European Union to that in High income: nonOECD?
Give a very brief answer. 16.64. What is the ratio of the Aid flow (current US$) of Belgium in European Union to that in High income: nonOECD?
Make the answer very short. 3.31. What is the ratio of the Aid flow (current US$) in Denmark in European Union to that in High income: nonOECD?
Give a very brief answer. 1.26. What is the ratio of the Aid flow (current US$) in Korea in European Union to that in High income: nonOECD?
Your response must be concise. 9.53. What is the ratio of the Aid flow (current US$) in Austria in European Union to that in High income: OECD?
Keep it short and to the point. 1.04. What is the ratio of the Aid flow (current US$) in Belgium in European Union to that in High income: OECD?
Keep it short and to the point. 1.3. What is the ratio of the Aid flow (current US$) of Denmark in European Union to that in High income: OECD?
Offer a terse response. 1.63. What is the ratio of the Aid flow (current US$) in Korea in European Union to that in High income: OECD?
Keep it short and to the point. 30.77. What is the ratio of the Aid flow (current US$) in Austria in Fragile and conflict affected situations to that in Heavily indebted poor countries?
Your response must be concise. 1.23. What is the ratio of the Aid flow (current US$) of Belgium in Fragile and conflict affected situations to that in Heavily indebted poor countries?
Offer a very short reply. 0.3. What is the ratio of the Aid flow (current US$) in Denmark in Fragile and conflict affected situations to that in Heavily indebted poor countries?
Offer a very short reply. 0.12. What is the ratio of the Aid flow (current US$) in Korea in Fragile and conflict affected situations to that in Heavily indebted poor countries?
Offer a terse response. 0.62. What is the ratio of the Aid flow (current US$) in Austria in Fragile and conflict affected situations to that in High income?
Keep it short and to the point. 0.62. What is the ratio of the Aid flow (current US$) of Belgium in Fragile and conflict affected situations to that in High income?
Keep it short and to the point. 6.95. What is the ratio of the Aid flow (current US$) of Denmark in Fragile and conflict affected situations to that in High income?
Provide a short and direct response. 1.18. What is the ratio of the Aid flow (current US$) of Korea in Fragile and conflict affected situations to that in High income?
Offer a very short reply. 3.38. What is the ratio of the Aid flow (current US$) in Austria in Fragile and conflict affected situations to that in High income: nonOECD?
Provide a succinct answer. 10.5. What is the ratio of the Aid flow (current US$) of Belgium in Fragile and conflict affected situations to that in High income: nonOECD?
Offer a terse response. 24.65. What is the ratio of the Aid flow (current US$) in Denmark in Fragile and conflict affected situations to that in High income: nonOECD?
Your answer should be very brief. 2.1. What is the ratio of the Aid flow (current US$) in Korea in Fragile and conflict affected situations to that in High income: nonOECD?
Provide a short and direct response. 4.42. What is the ratio of the Aid flow (current US$) in Austria in Fragile and conflict affected situations to that in High income: OECD?
Offer a very short reply. 0.66. What is the ratio of the Aid flow (current US$) in Belgium in Fragile and conflict affected situations to that in High income: OECD?
Provide a succinct answer. 9.68. What is the ratio of the Aid flow (current US$) of Denmark in Fragile and conflict affected situations to that in High income: OECD?
Provide a succinct answer. 2.72. What is the ratio of the Aid flow (current US$) in Korea in Fragile and conflict affected situations to that in High income: OECD?
Ensure brevity in your answer.  14.29. What is the ratio of the Aid flow (current US$) in Austria in Heavily indebted poor countries to that in High income?
Provide a short and direct response. 0.5. What is the ratio of the Aid flow (current US$) in Belgium in Heavily indebted poor countries to that in High income?
Offer a terse response. 23.22. What is the ratio of the Aid flow (current US$) in Denmark in Heavily indebted poor countries to that in High income?
Your answer should be very brief. 9.72. What is the ratio of the Aid flow (current US$) in Korea in Heavily indebted poor countries to that in High income?
Offer a very short reply. 5.45. What is the ratio of the Aid flow (current US$) in Austria in Heavily indebted poor countries to that in High income: nonOECD?
Make the answer very short. 8.55. What is the ratio of the Aid flow (current US$) in Belgium in Heavily indebted poor countries to that in High income: nonOECD?
Your answer should be very brief. 82.36. What is the ratio of the Aid flow (current US$) in Denmark in Heavily indebted poor countries to that in High income: nonOECD?
Give a very brief answer. 17.22. What is the ratio of the Aid flow (current US$) of Korea in Heavily indebted poor countries to that in High income: nonOECD?
Your answer should be very brief. 7.13. What is the ratio of the Aid flow (current US$) in Austria in Heavily indebted poor countries to that in High income: OECD?
Offer a terse response. 0.53. What is the ratio of the Aid flow (current US$) in Belgium in Heavily indebted poor countries to that in High income: OECD?
Offer a very short reply. 32.34. What is the ratio of the Aid flow (current US$) in Denmark in Heavily indebted poor countries to that in High income: OECD?
Provide a succinct answer. 22.29. What is the ratio of the Aid flow (current US$) in Korea in Heavily indebted poor countries to that in High income: OECD?
Make the answer very short. 23.03. What is the ratio of the Aid flow (current US$) in Austria in High income to that in High income: nonOECD?
Offer a terse response. 16.99. What is the ratio of the Aid flow (current US$) in Belgium in High income to that in High income: nonOECD?
Offer a very short reply. 3.55. What is the ratio of the Aid flow (current US$) of Denmark in High income to that in High income: nonOECD?
Provide a succinct answer. 1.77. What is the ratio of the Aid flow (current US$) in Korea in High income to that in High income: nonOECD?
Provide a succinct answer. 1.31. What is the ratio of the Aid flow (current US$) in Austria in High income to that in High income: OECD?
Make the answer very short. 1.06. What is the ratio of the Aid flow (current US$) of Belgium in High income to that in High income: OECD?
Provide a short and direct response. 1.39. What is the ratio of the Aid flow (current US$) of Denmark in High income to that in High income: OECD?
Give a very brief answer. 2.29. What is the ratio of the Aid flow (current US$) in Korea in High income to that in High income: OECD?
Your answer should be compact. 4.23. What is the ratio of the Aid flow (current US$) of Austria in High income: nonOECD to that in High income: OECD?
Your answer should be compact. 0.06. What is the ratio of the Aid flow (current US$) of Belgium in High income: nonOECD to that in High income: OECD?
Make the answer very short. 0.39. What is the ratio of the Aid flow (current US$) in Denmark in High income: nonOECD to that in High income: OECD?
Give a very brief answer. 1.29. What is the ratio of the Aid flow (current US$) in Korea in High income: nonOECD to that in High income: OECD?
Your response must be concise. 3.23. What is the difference between the highest and the second highest Aid flow (current US$) in Austria?
Provide a short and direct response. 3.84e+06. What is the difference between the highest and the second highest Aid flow (current US$) in Belgium?
Provide a succinct answer. 1.49e+08. What is the difference between the highest and the second highest Aid flow (current US$) in Denmark?
Provide a short and direct response. 3.67e+08. What is the difference between the highest and the second highest Aid flow (current US$) in Korea?
Offer a terse response. 2.71e+06. What is the difference between the highest and the lowest Aid flow (current US$) in Austria?
Ensure brevity in your answer.  1.77e+08. What is the difference between the highest and the lowest Aid flow (current US$) in Belgium?
Provide a short and direct response. 2.10e+08. What is the difference between the highest and the lowest Aid flow (current US$) of Denmark?
Your answer should be very brief. 3.99e+08. What is the difference between the highest and the lowest Aid flow (current US$) of Korea?
Keep it short and to the point. 1.04e+07. 